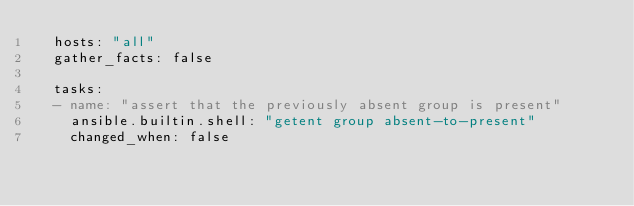<code> <loc_0><loc_0><loc_500><loc_500><_YAML_>  hosts: "all"
  gather_facts: false

  tasks:
  - name: "assert that the previously absent group is present"
    ansible.builtin.shell: "getent group absent-to-present"
    changed_when: false
</code> 